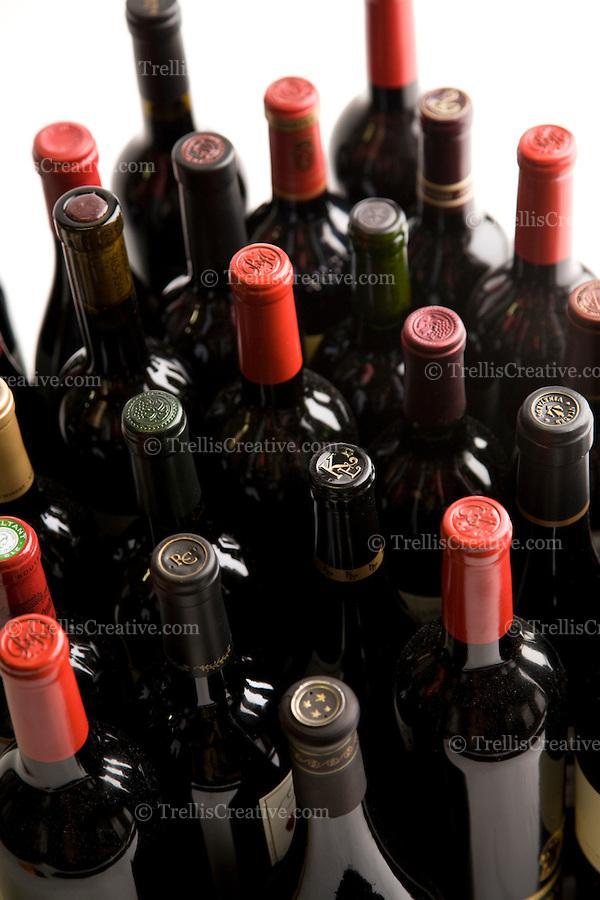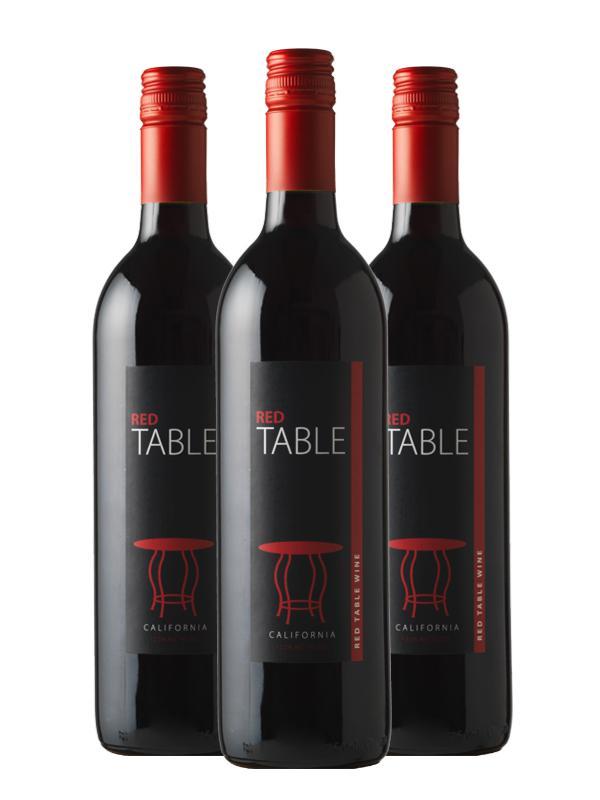The first image is the image on the left, the second image is the image on the right. Assess this claim about the two images: "An image includes at least one wine bottle and wine glass.". Correct or not? Answer yes or no. No. The first image is the image on the left, the second image is the image on the right. Examine the images to the left and right. Is the description "A single bottle of wine is shown in one image." accurate? Answer yes or no. No. 